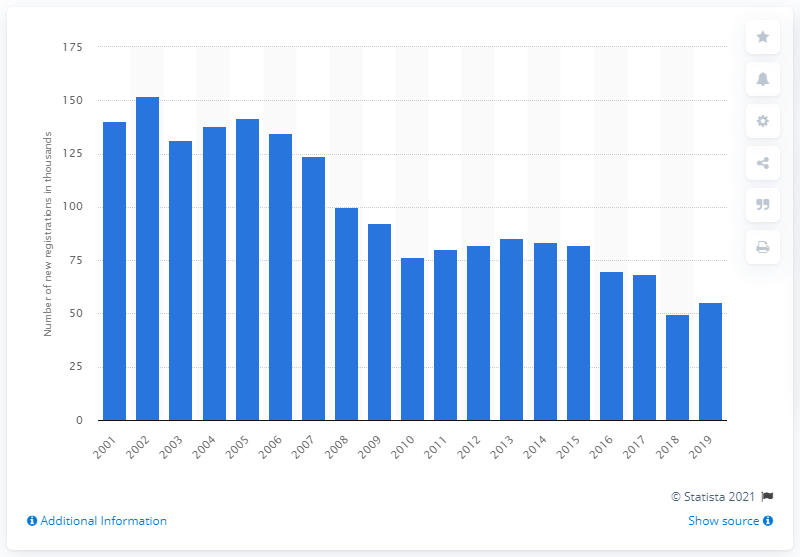Identify some key points in this picture. The first Ford Focus passenger car was registered for the first time in Great Britain in the year 2001. 